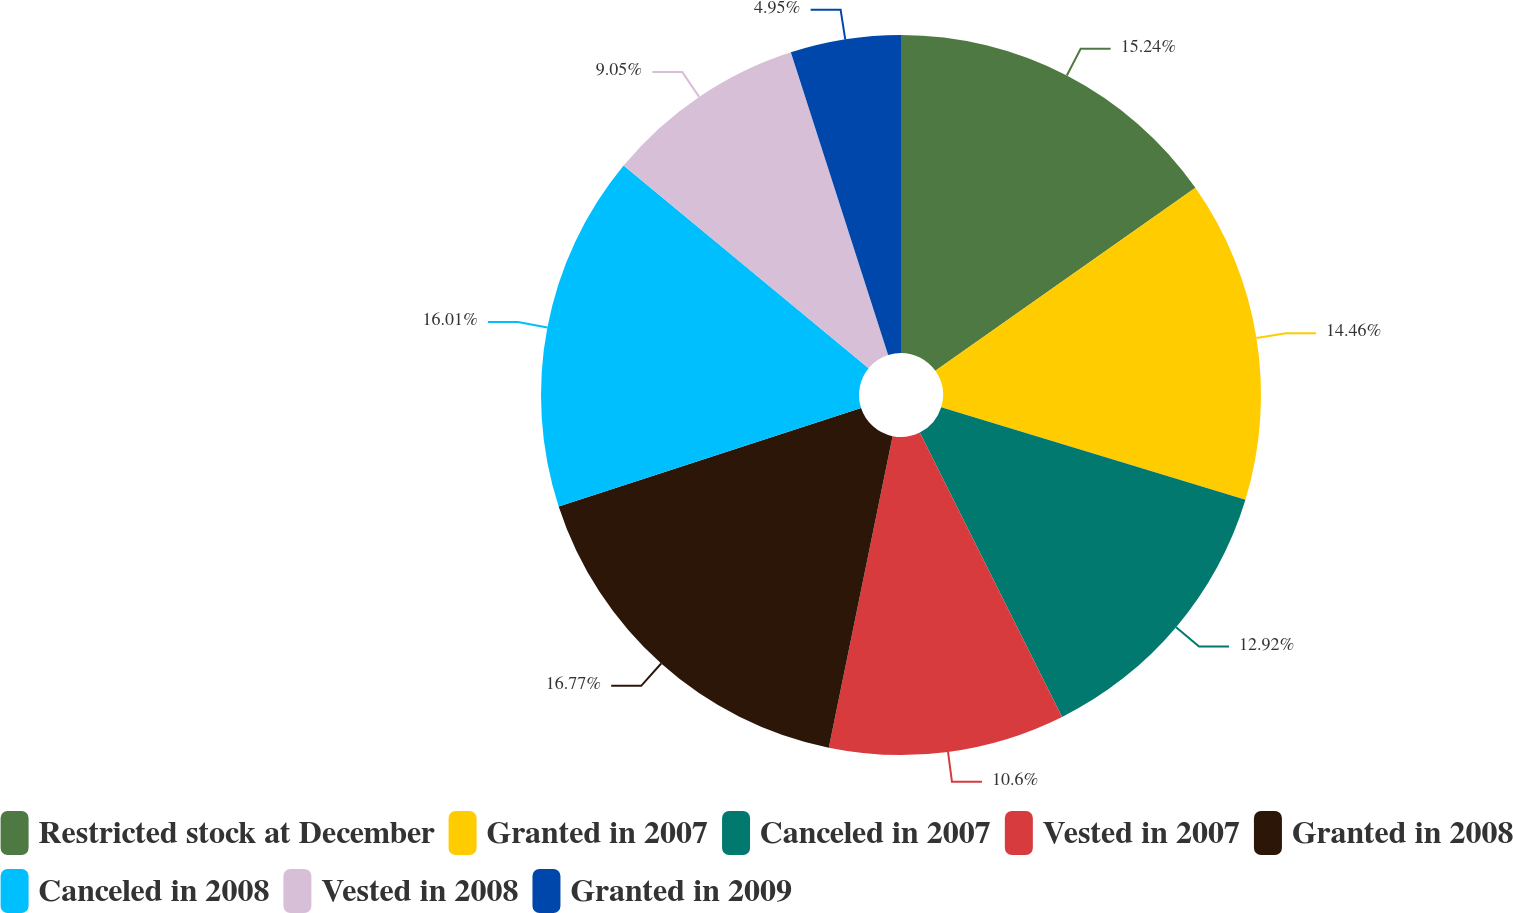<chart> <loc_0><loc_0><loc_500><loc_500><pie_chart><fcel>Restricted stock at December<fcel>Granted in 2007<fcel>Canceled in 2007<fcel>Vested in 2007<fcel>Granted in 2008<fcel>Canceled in 2008<fcel>Vested in 2008<fcel>Granted in 2009<nl><fcel>15.24%<fcel>14.46%<fcel>12.92%<fcel>10.6%<fcel>16.78%<fcel>16.01%<fcel>9.05%<fcel>4.95%<nl></chart> 